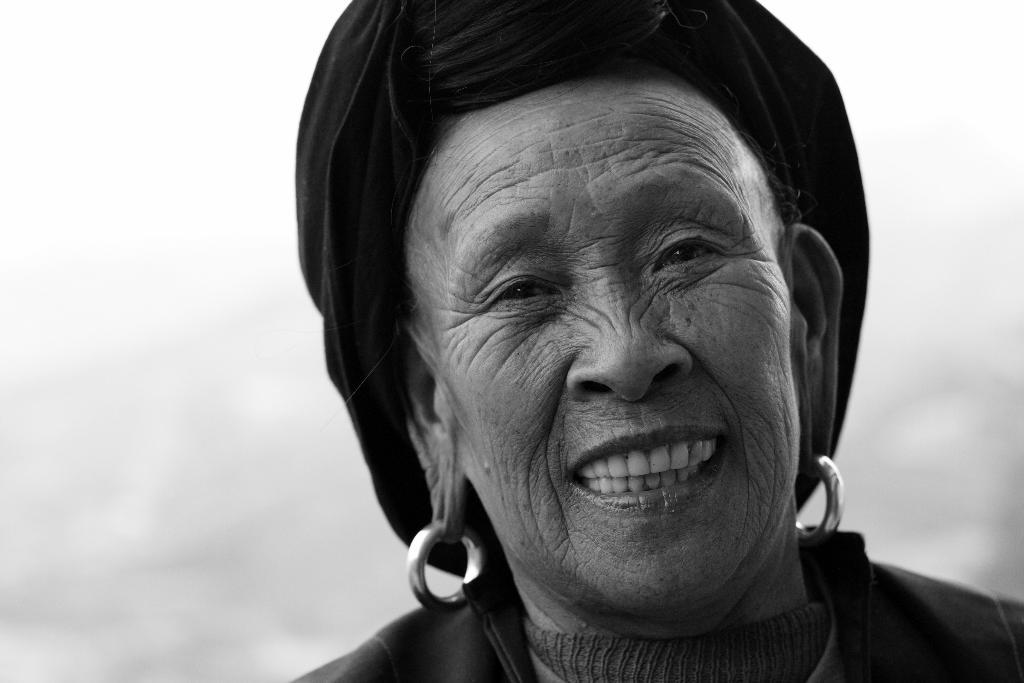What is the main subject of the image? There is a person's face in the image. What can be seen in the background of the image? The sky is visible in the image. How is the image presented in terms of color? The image is in black and white. What type of produce is being held by the person in the image? There is no produce present in the image, as it only features a person's face and the sky in the background. 